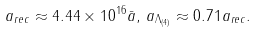<formula> <loc_0><loc_0><loc_500><loc_500>a _ { r e c } \approx 4 . 4 4 \times 1 0 ^ { 1 6 } \bar { a } , \, a _ { \Lambda _ { ( 4 ) } } \approx 0 . 7 1 a _ { r e c } .</formula> 